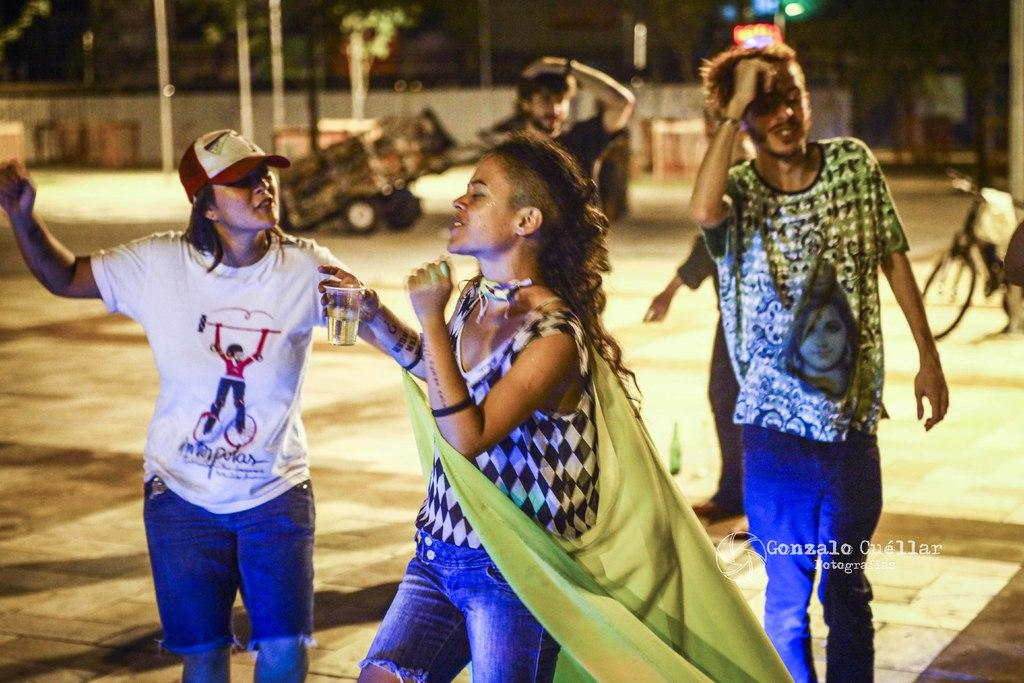How many people are in the image? There are persons in the image, but the exact number is not specified. What type of transportation is visible in the image? There is a bicycle and a vehicle in the image. What can be seen in the background of the image? There are poles, trees, a light, and a wall in the background of the image. What type of mitten is being used as a prop in the image? There is no mitten present in the image. What punishment is being administered to the person riding the bicycle in the image? There is no punishment being administered to anyone in the image. 